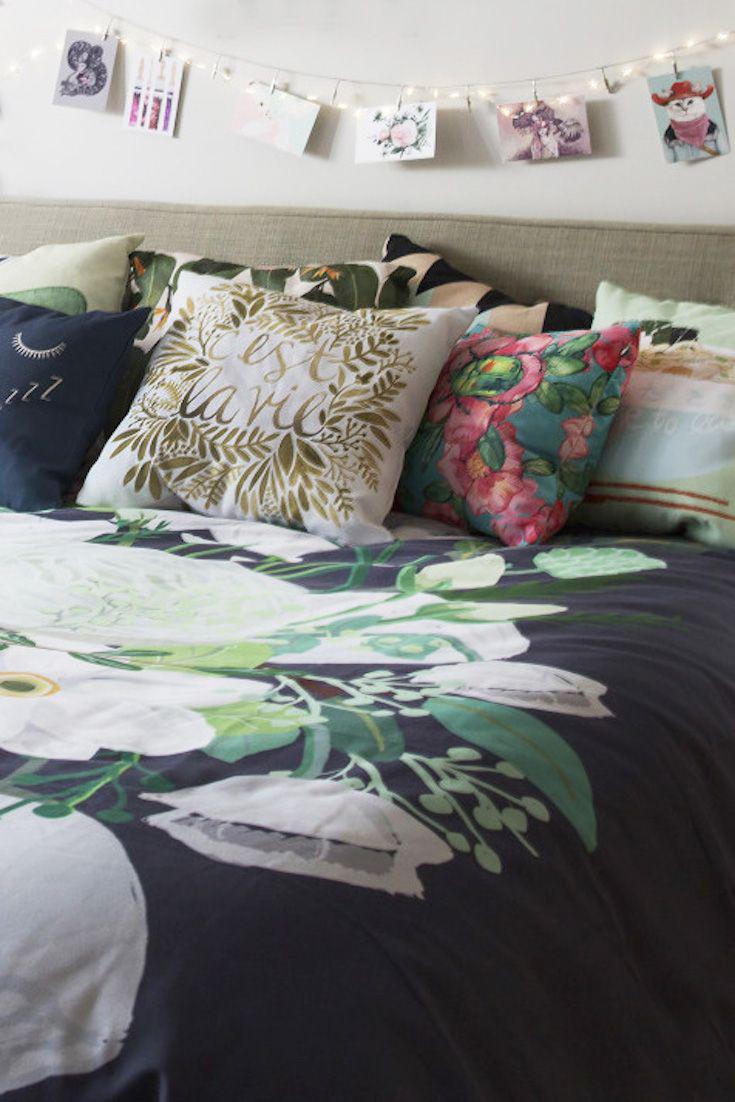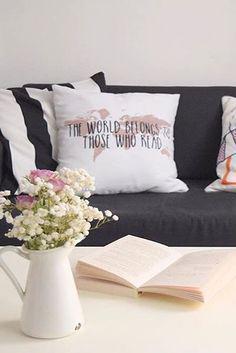The first image is the image on the left, the second image is the image on the right. Given the left and right images, does the statement "An image shows a printed bedspread with no throw pillows on top or people under it." hold true? Answer yes or no. No. The first image is the image on the left, the second image is the image on the right. For the images shown, is this caption "There are at least five pillows, more in one image than the other." true? Answer yes or no. Yes. 